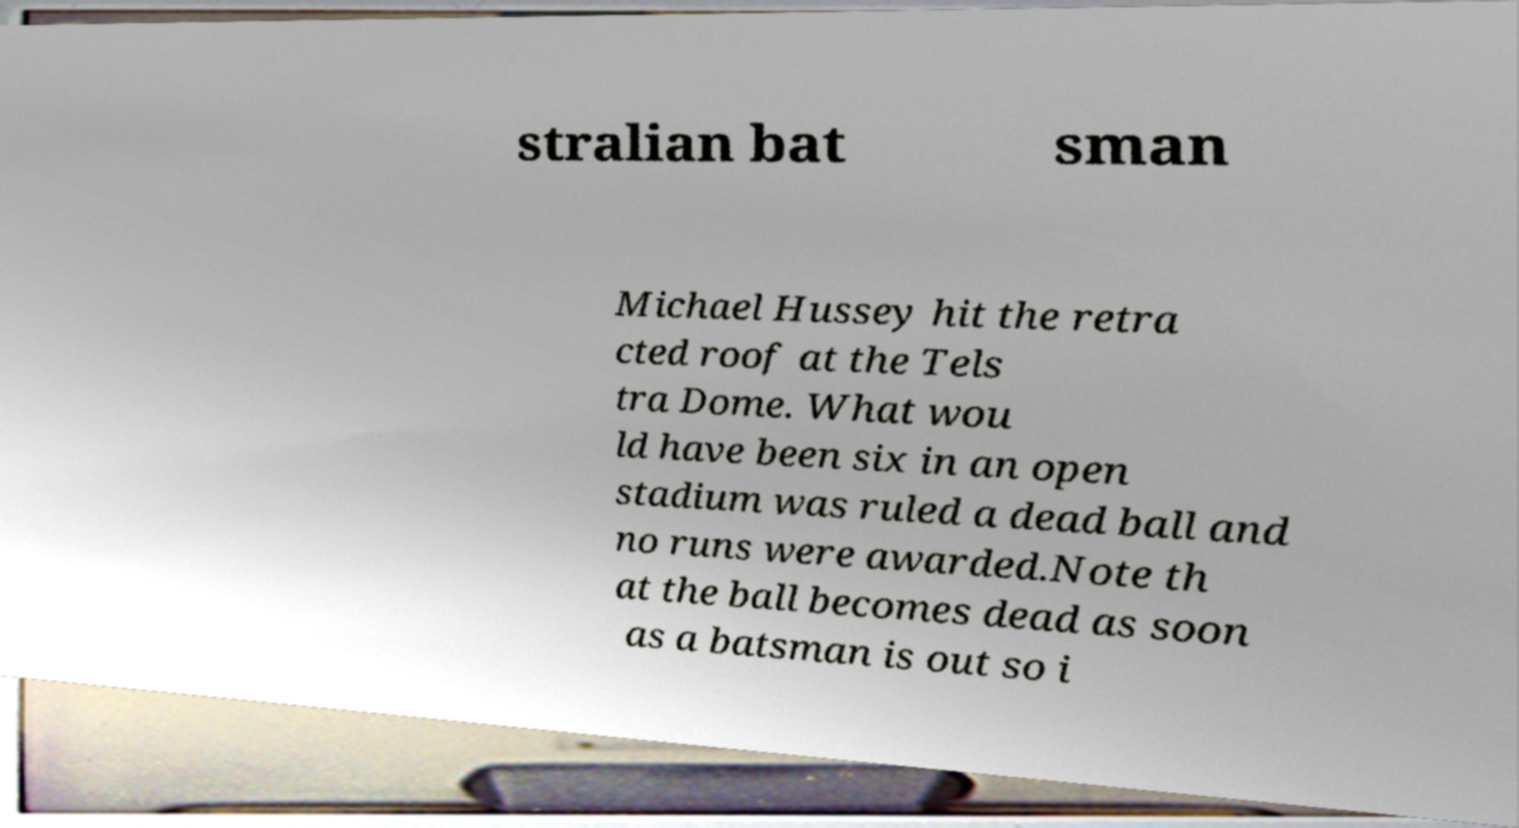Could you extract and type out the text from this image? stralian bat sman Michael Hussey hit the retra cted roof at the Tels tra Dome. What wou ld have been six in an open stadium was ruled a dead ball and no runs were awarded.Note th at the ball becomes dead as soon as a batsman is out so i 